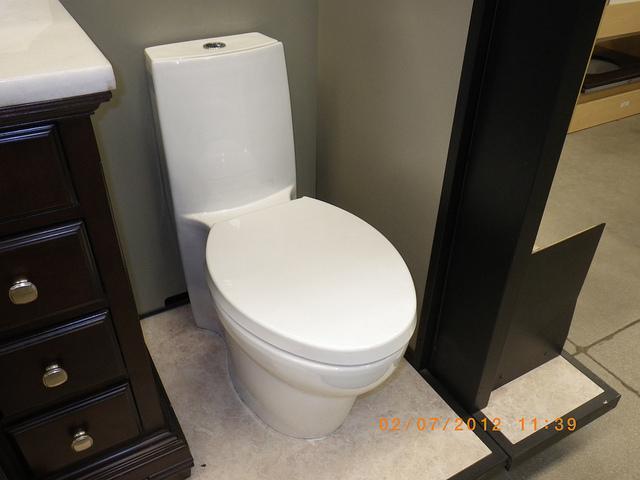How many drawers are there?
Give a very brief answer. 4. 